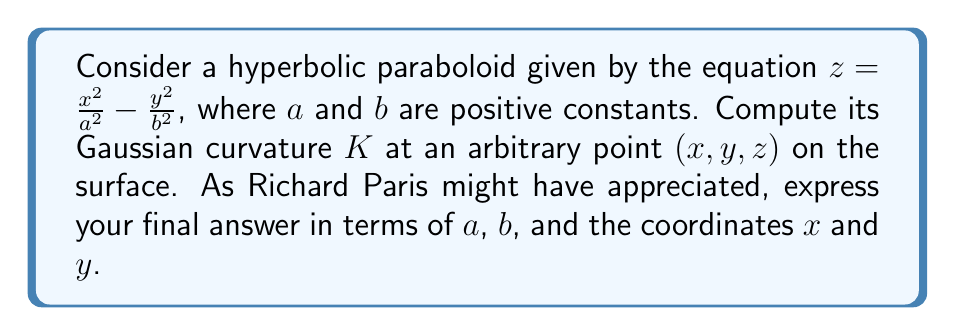Give your solution to this math problem. Let's approach this step-by-step:

1) First, we need to calculate the first and second partial derivatives of $z$ with respect to $x$ and $y$:

   $z_x = \frac{2x}{a^2}$, $z_y = -\frac{2y}{b^2}$
   $z_{xx} = \frac{2}{a^2}$, $z_{yy} = -\frac{2}{b^2}$, $z_{xy} = z_{yx} = 0$

2) Now, we can compute the coefficients of the first fundamental form:

   $E = 1 + z_x^2 = 1 + \frac{4x^2}{a^4}$
   $F = z_x z_y = -\frac{4xy}{a^2b^2}$
   $G = 1 + z_y^2 = 1 + \frac{4y^2}{b^4}$

3) Next, we calculate the coefficients of the second fundamental form:

   $L = \frac{z_{xx}}{\sqrt{1 + z_x^2 + z_y^2}} = \frac{2/a^2}{\sqrt{1 + \frac{4x^2}{a^4} + \frac{4y^2}{b^4}}}$
   $M = \frac{z_{xy}}{\sqrt{1 + z_x^2 + z_y^2}} = 0$
   $N = \frac{z_{yy}}{\sqrt{1 + z_x^2 + z_y^2}} = \frac{-2/b^2}{\sqrt{1 + \frac{4x^2}{a^4} + \frac{4y^2}{b^4}}}$

4) The Gaussian curvature is given by:

   $K = \frac{LN - M^2}{EG - F^2}$

5) Substituting the values:

   $K = \frac{(\frac{2}{a^2})(-\frac{2}{b^2}) - 0^2}{(1 + \frac{4x^2}{a^4})(1 + \frac{4y^2}{b^4}) - (\frac{4xy}{a^2b^2})^2}$

6) Simplifying:

   $K = \frac{-\frac{4}{a^2b^2}}{1 + \frac{4x^2}{a^4} + \frac{4y^2}{b^4} + \frac{16x^2y^2}{a^4b^4} - \frac{16x^2y^2}{a^4b^4}}$

7) Further simplification yields:

   $K = \frac{-4}{a^2b^2(1 + \frac{4x^2}{a^4} + \frac{4y^2}{b^4})}$

This is our final expression for the Gaussian curvature at any point $(x, y, z)$ on the hyperbolic paraboloid.
Answer: $K = \frac{-4}{a^2b^2(1 + \frac{4x^2}{a^4} + \frac{4y^2}{b^4})}$ 